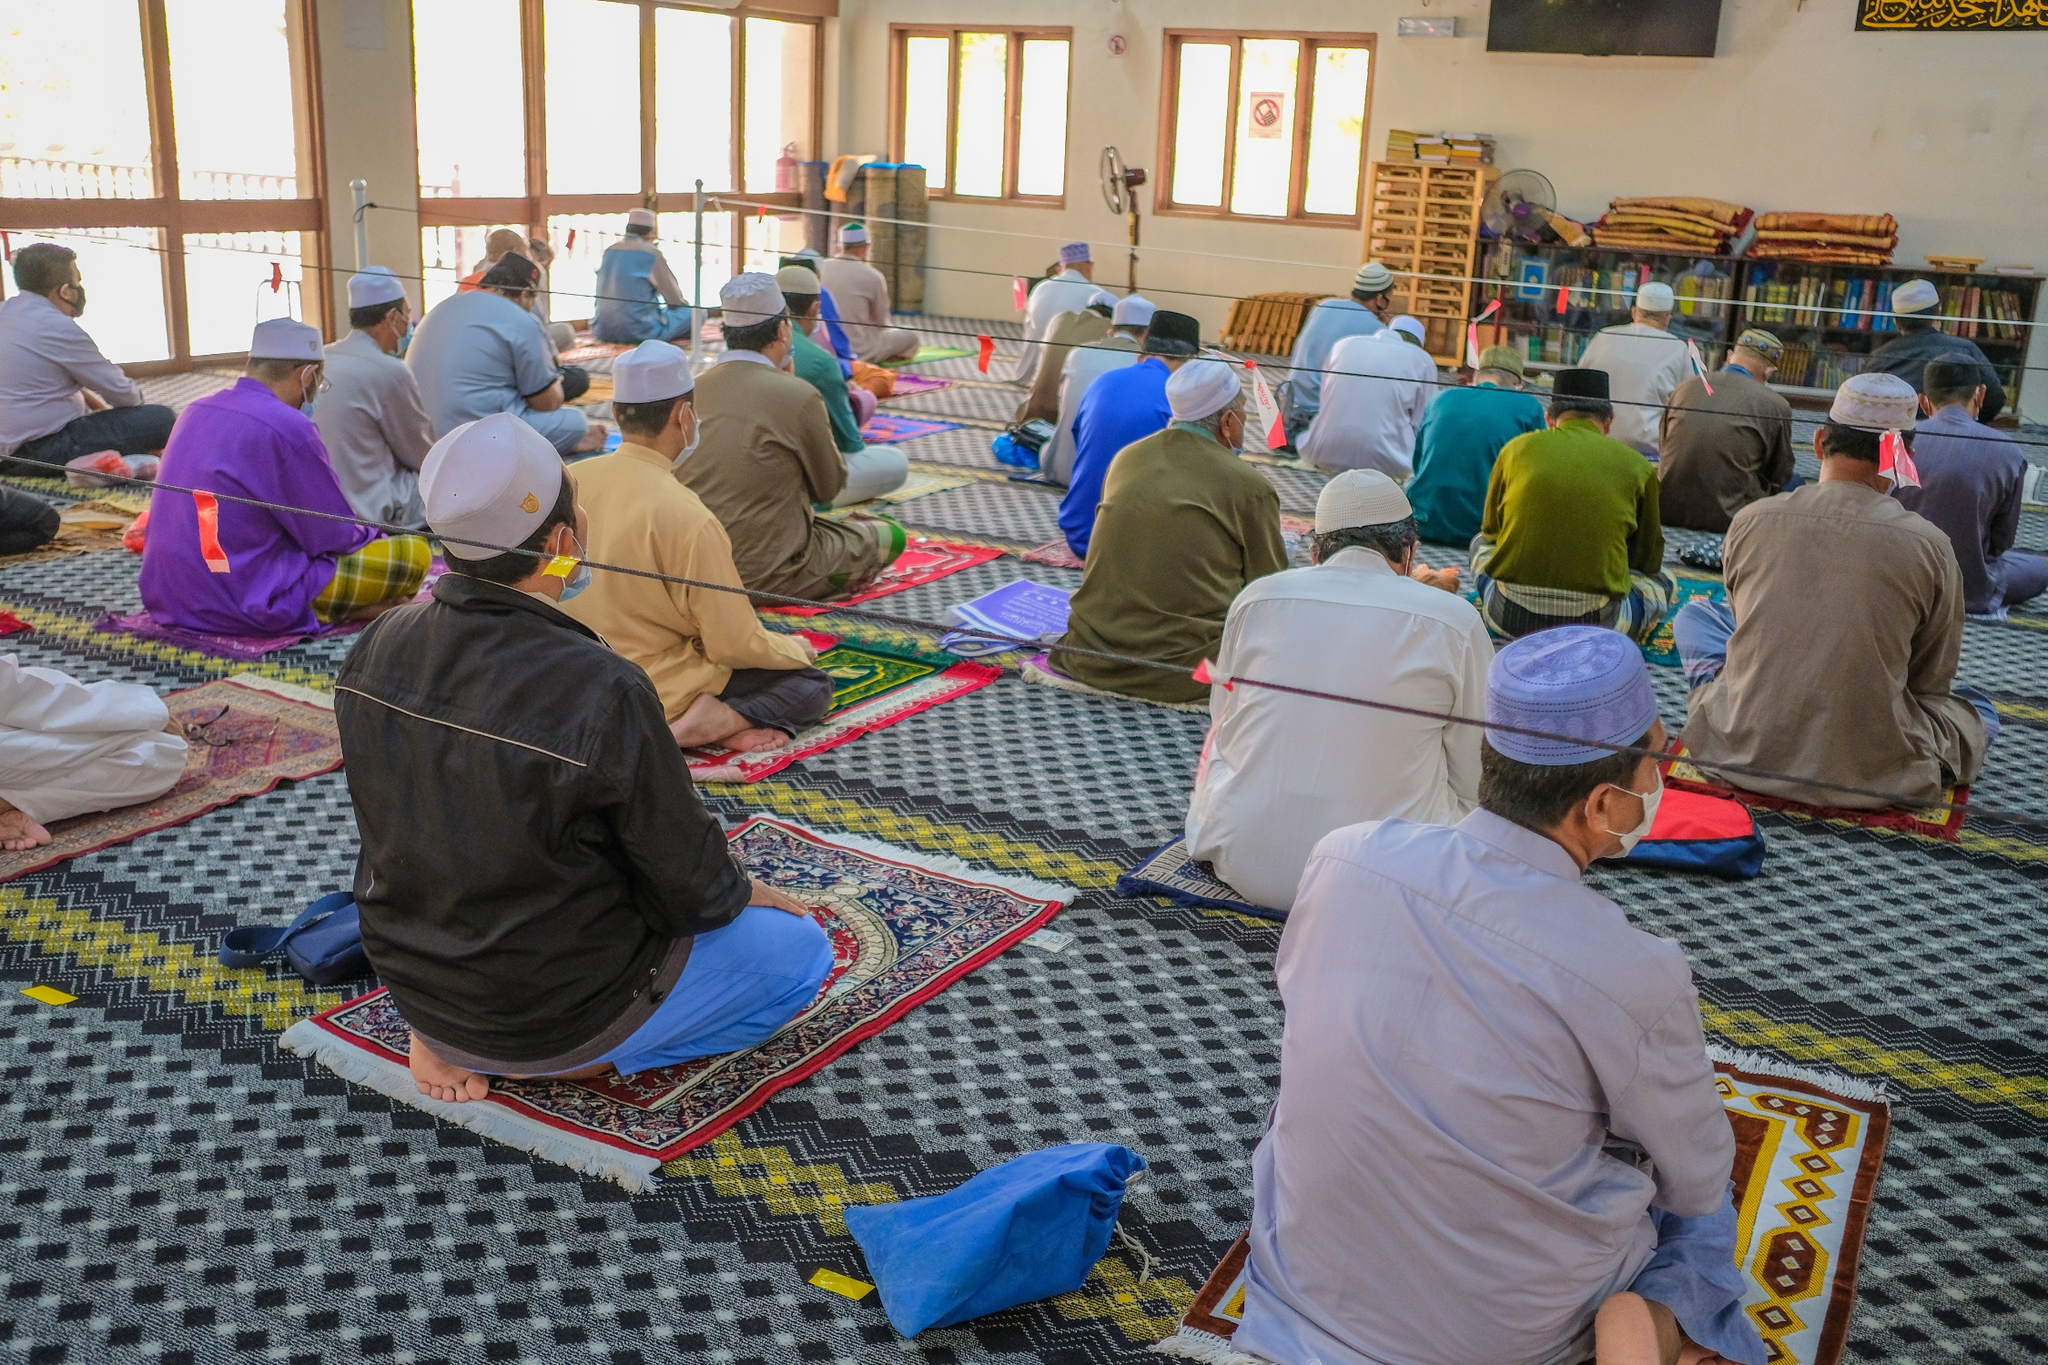Can you elaborate on the elements of the picture provided? The image captures a serene moment inside a mosque. From a high vantage point, we see a group of people engaged in prayer, sitting on vibrant prayer rugs that add a splash of color to the scene. The individuals, mostly men, are organized in neat rows, all facing the sharegpt4v/same direction, which showcases unity and communal worship. The room itself is spacious and well-lit, with sunlight streaming in through the expansive windows that create an airy atmosphere. You can observe bookshelves along the walls, filled with various books, hinting at the mosque being not only a place of worship but also a center of learning and reflection. The people in prayer seem to be in a state of deep devotion and tranquility, contributing to an overall sense of peace and community. Additionally, the visible safety measures, such as the mask-wearing attendees and the distancing markers, indicate a conscious effort to maintain health protocols. 